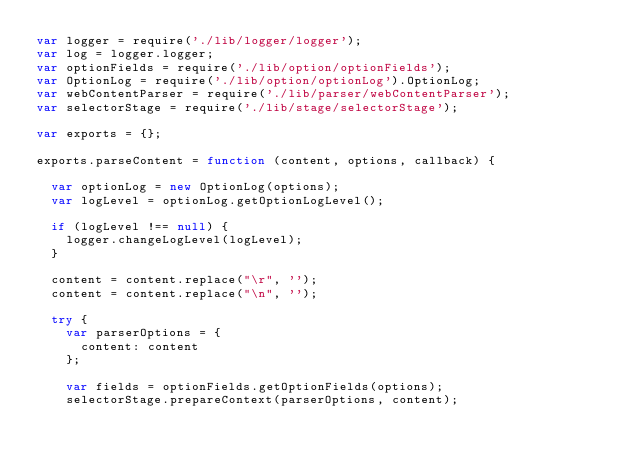<code> <loc_0><loc_0><loc_500><loc_500><_JavaScript_>var logger = require('./lib/logger/logger');
var log = logger.logger;
var optionFields = require('./lib/option/optionFields');
var OptionLog = require('./lib/option/optionLog').OptionLog;
var webContentParser = require('./lib/parser/webContentParser');
var selectorStage = require('./lib/stage/selectorStage');

var exports = {};

exports.parseContent = function (content, options, callback) {

  var optionLog = new OptionLog(options);
  var logLevel = optionLog.getOptionLogLevel();

  if (logLevel !== null) {
    logger.changeLogLevel(logLevel);
  }

  content = content.replace("\r", '');
  content = content.replace("\n", '');

  try {
    var parserOptions = {
      content: content
    };

    var fields = optionFields.getOptionFields(options);
    selectorStage.prepareContext(parserOptions, content);
</code> 